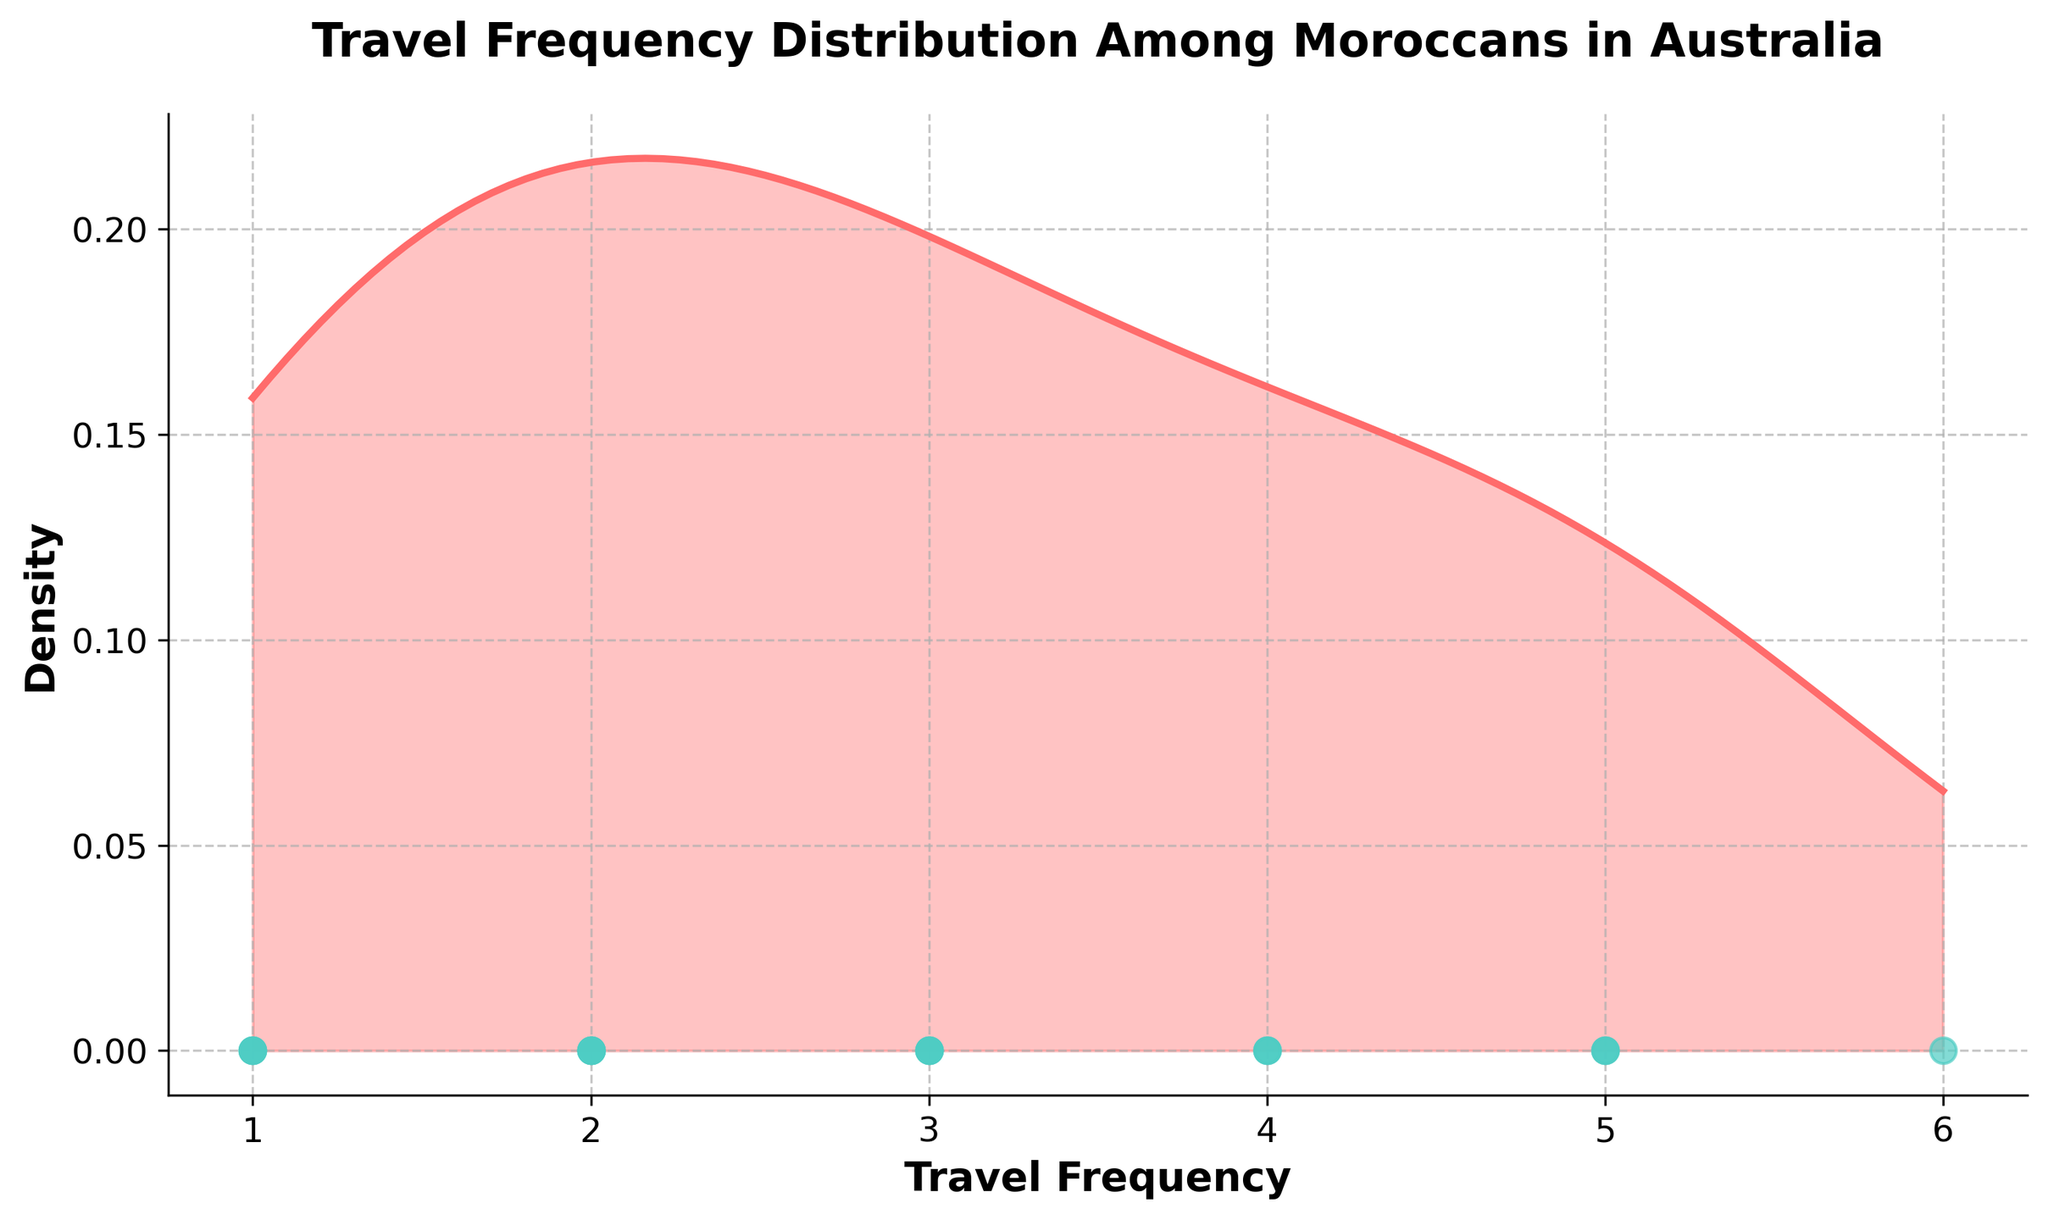What is the title of the figure? The title is usually displayed at the top of the figure. In this case, it is indicated by a bold and larger font size.
Answer: Travel Frequency Distribution Among Moroccans in Australia What are the labels of the x-axis and y-axis? The labels are typically found next to the axes of the plot. The x-axis label is usually at the bottom, and the y-axis label is at the side.
Answer: Travel Frequency (x-axis) and Density (y-axis) How many data points are shown as blue circles? The number of data points can be counted directly from the scatter plot where the points are represented by blue circles.
Answer: 20 What is the peak value of the density curve? The peak value of a density curve is the highest point on the curve, which can be visually identified as the maximum y-value on the curve.
Answer: About 0.1 What is the range of Travel Frequency values shown on the x-axis? The range of values on the x-axis can be deduced by looking at the minimum and maximum values displayed along the x-axis.
Answer: 1 to 6 Which Travel Frequency value appears most frequently? To determine the most frequent value, look for where the density plot has its highest peak along the x-axis.
Answer: 5 How many Travel Frequency values are greater than 3? Count the number of data points (blue circles) that are positioned above the value 3 on the x-axis.
Answer: 7 What is the mean Travel Frequency value? The mean value is calculated by summing all Travel Frequency values and dividing by the number of data points. Sum: (5+2+1+3+6+4+2+3+1+2+3+5+2+1+4+4+1+2+5+3)=55. Divide by 20 points: 55/20
Answer: 2.75 Does the density plot show any clusters of Travel Frequency values? Clusters can be identified by peaks or concentrations in the density curve, indicating where points are most densely populated. The highest peaks show where clustering occurs.
Answer: Yes, especially at values 3, 4, and 5 Is the data more spread out or clustered around certain Travel Frequency values? The spread or clustering can be observed from the density curve. If the curve has prominent peaks and few broad regions, it indicates clustering around certain values.
Answer: Clustered around certain values 